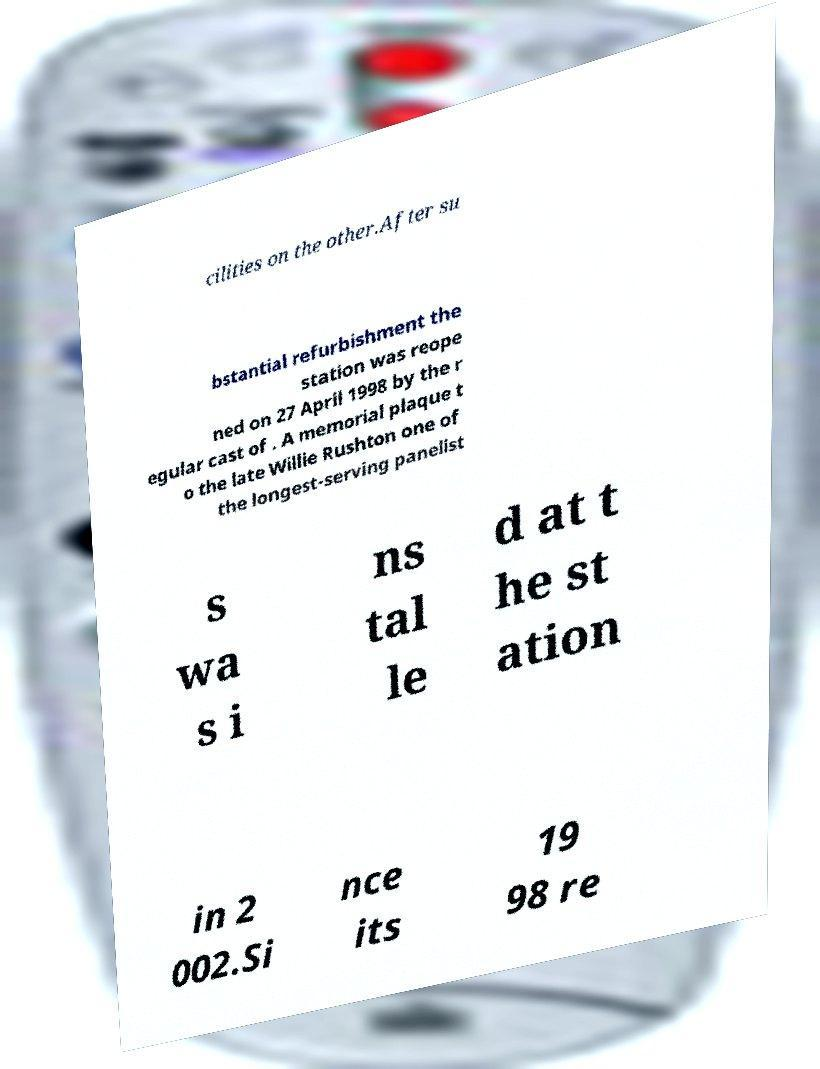Can you read and provide the text displayed in the image?This photo seems to have some interesting text. Can you extract and type it out for me? cilities on the other.After su bstantial refurbishment the station was reope ned on 27 April 1998 by the r egular cast of . A memorial plaque t o the late Willie Rushton one of the longest-serving panelist s wa s i ns tal le d at t he st ation in 2 002.Si nce its 19 98 re 